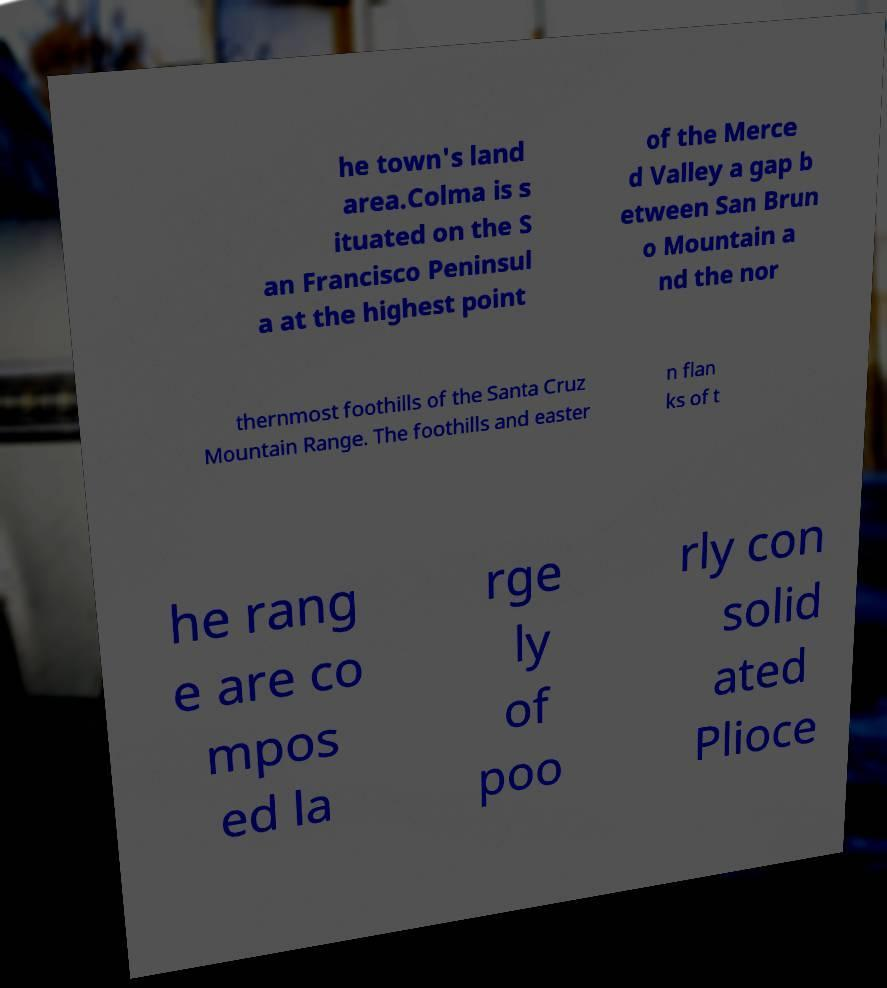Can you accurately transcribe the text from the provided image for me? he town's land area.Colma is s ituated on the S an Francisco Peninsul a at the highest point of the Merce d Valley a gap b etween San Brun o Mountain a nd the nor thernmost foothills of the Santa Cruz Mountain Range. The foothills and easter n flan ks of t he rang e are co mpos ed la rge ly of poo rly con solid ated Plioce 